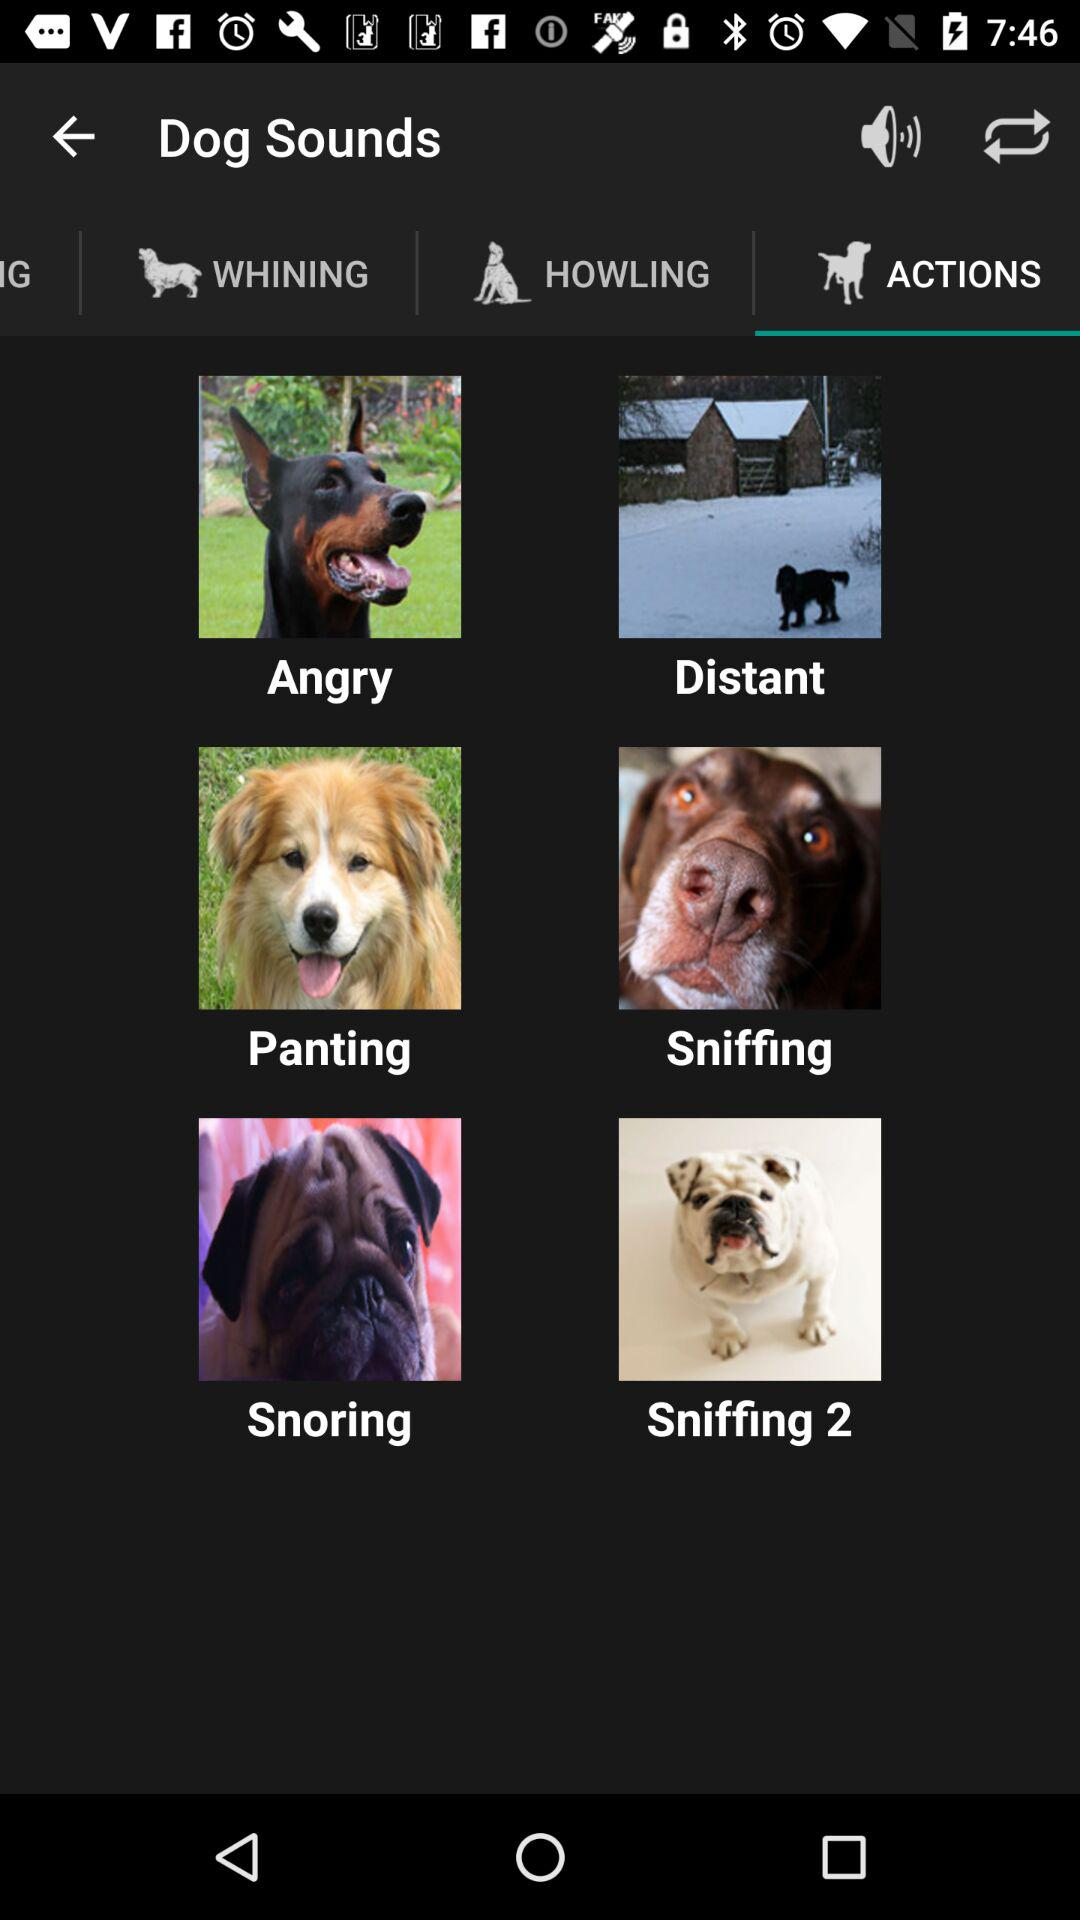On which tab am I now? You are now on the "ACTIONS" tab. 